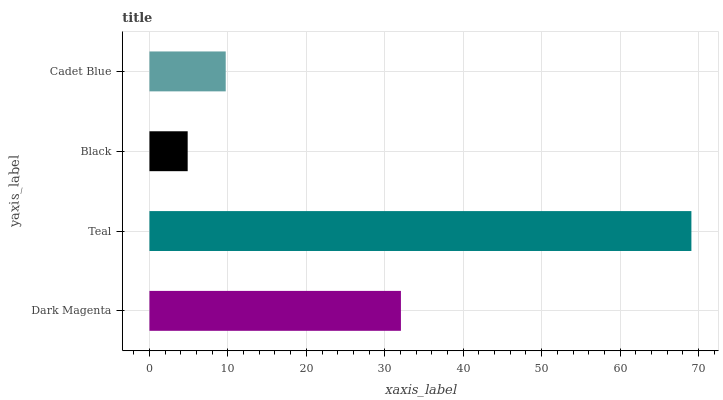Is Black the minimum?
Answer yes or no. Yes. Is Teal the maximum?
Answer yes or no. Yes. Is Teal the minimum?
Answer yes or no. No. Is Black the maximum?
Answer yes or no. No. Is Teal greater than Black?
Answer yes or no. Yes. Is Black less than Teal?
Answer yes or no. Yes. Is Black greater than Teal?
Answer yes or no. No. Is Teal less than Black?
Answer yes or no. No. Is Dark Magenta the high median?
Answer yes or no. Yes. Is Cadet Blue the low median?
Answer yes or no. Yes. Is Cadet Blue the high median?
Answer yes or no. No. Is Teal the low median?
Answer yes or no. No. 